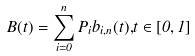Convert formula to latex. <formula><loc_0><loc_0><loc_500><loc_500>B ( t ) = \sum _ { i = 0 } ^ { n } P _ { i } b _ { i , n } ( t ) { , } t \in [ 0 , 1 ]</formula> 